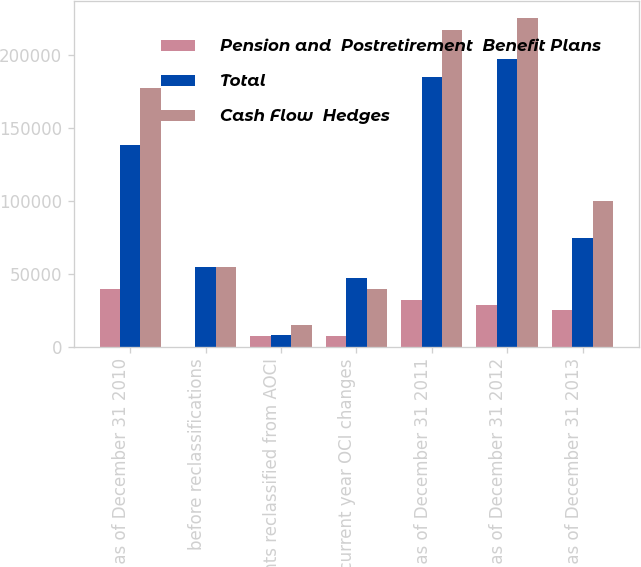Convert chart. <chart><loc_0><loc_0><loc_500><loc_500><stacked_bar_chart><ecel><fcel>Balance as of December 31 2010<fcel>before reclassifications<fcel>Amounts reclassified from AOCI<fcel>Net current year OCI changes<fcel>Balance as of December 31 2011<fcel>Balance as of December 31 2012<fcel>Balance as of December 31 2013<nl><fcel>Pension and  Postretirement  Benefit Plans<fcel>39137<fcel>0<fcel>7151<fcel>7151<fcel>31986<fcel>28170<fcel>25178<nl><fcel>Total<fcel>138202<fcel>54366<fcel>7710<fcel>46656<fcel>184858<fcel>197347<fcel>74453<nl><fcel>Cash Flow  Hedges<fcel>177339<fcel>54366<fcel>14861<fcel>39505<fcel>216844<fcel>225517<fcel>99631<nl></chart> 